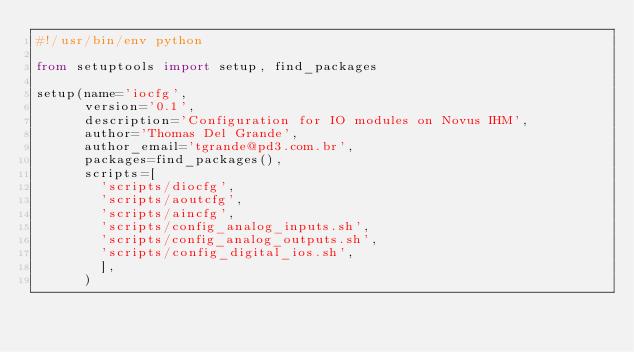Convert code to text. <code><loc_0><loc_0><loc_500><loc_500><_Python_>#!/usr/bin/env python

from setuptools import setup, find_packages

setup(name='iocfg',
      version='0.1',
      description='Configuration for IO modules on Novus IHM',
      author='Thomas Del Grande',
      author_email='tgrande@pd3.com.br',
      packages=find_packages(),
      scripts=[
        'scripts/diocfg',
        'scripts/aoutcfg',
        'scripts/aincfg',
        'scripts/config_analog_inputs.sh',
        'scripts/config_analog_outputs.sh',
        'scripts/config_digital_ios.sh',
        ],
      )
</code> 